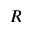Convert formula to latex. <formula><loc_0><loc_0><loc_500><loc_500>R</formula> 